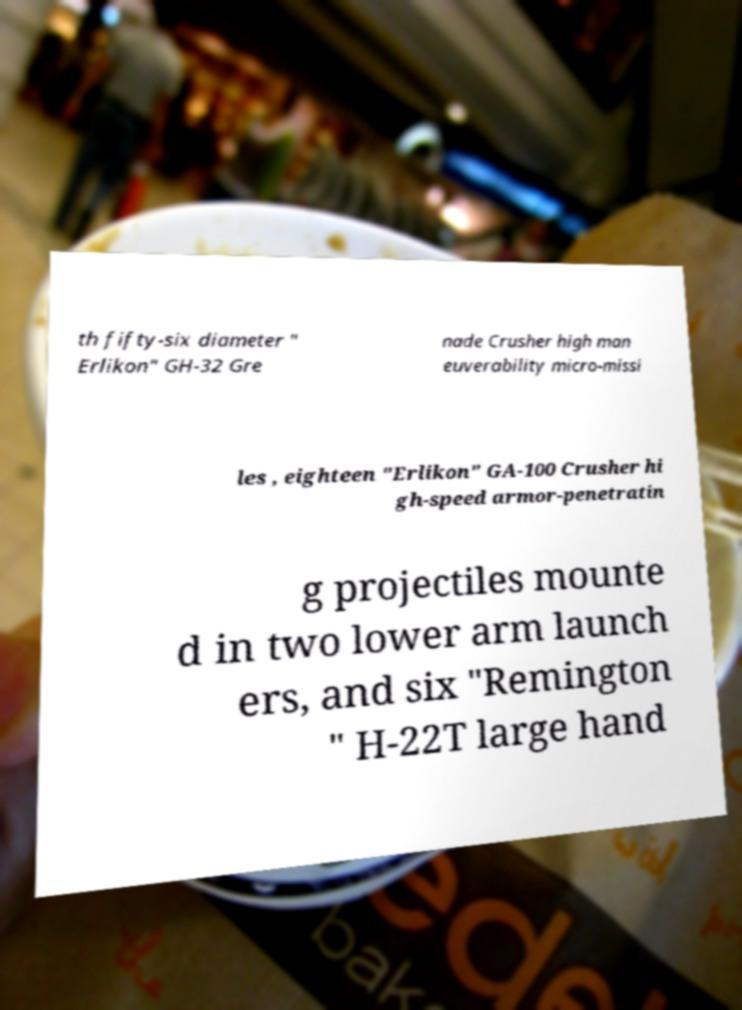For documentation purposes, I need the text within this image transcribed. Could you provide that? th fifty-six diameter " Erlikon" GH-32 Gre nade Crusher high man euverability micro-missi les , eighteen "Erlikon" GA-100 Crusher hi gh-speed armor-penetratin g projectiles mounte d in two lower arm launch ers, and six "Remington " H-22T large hand 